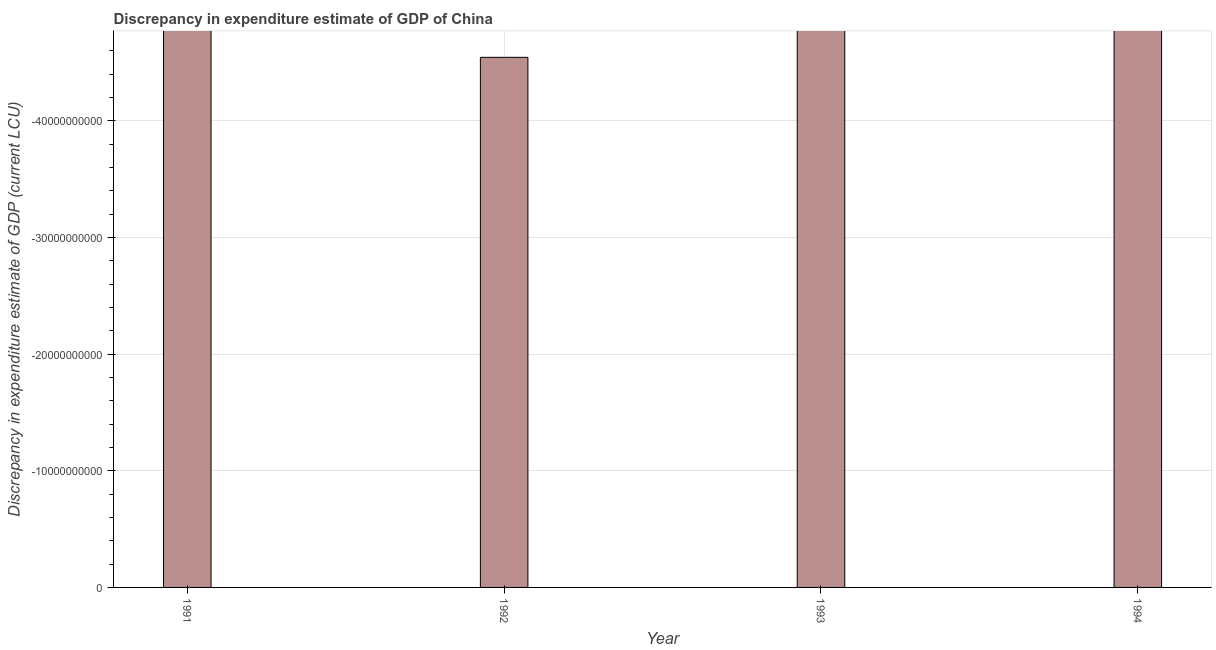What is the title of the graph?
Your answer should be very brief. Discrepancy in expenditure estimate of GDP of China. What is the label or title of the Y-axis?
Offer a terse response. Discrepancy in expenditure estimate of GDP (current LCU). What is the discrepancy in expenditure estimate of gdp in 1992?
Give a very brief answer. 0. What is the sum of the discrepancy in expenditure estimate of gdp?
Offer a very short reply. 0. In how many years, is the discrepancy in expenditure estimate of gdp greater than -32000000000 LCU?
Give a very brief answer. 0. In how many years, is the discrepancy in expenditure estimate of gdp greater than the average discrepancy in expenditure estimate of gdp taken over all years?
Ensure brevity in your answer.  0. Are all the bars in the graph horizontal?
Provide a succinct answer. No. Are the values on the major ticks of Y-axis written in scientific E-notation?
Your response must be concise. No. What is the Discrepancy in expenditure estimate of GDP (current LCU) in 1991?
Provide a short and direct response. 0. What is the Discrepancy in expenditure estimate of GDP (current LCU) of 1993?
Provide a short and direct response. 0. What is the Discrepancy in expenditure estimate of GDP (current LCU) in 1994?
Give a very brief answer. 0. 